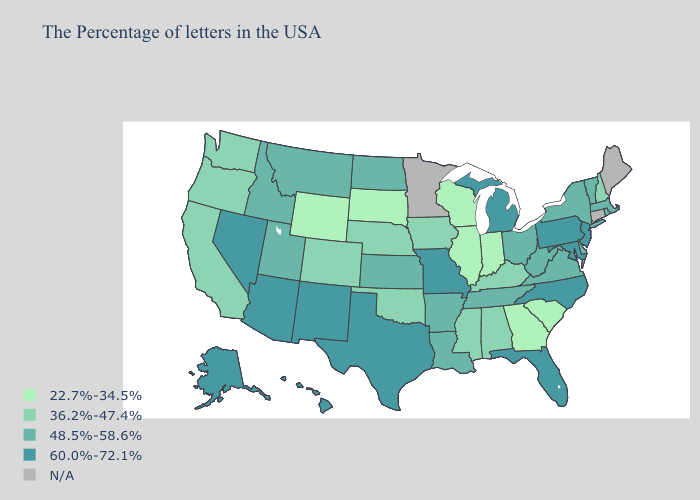What is the value of Washington?
Answer briefly. 36.2%-47.4%. Name the states that have a value in the range 48.5%-58.6%?
Quick response, please. Massachusetts, Rhode Island, Vermont, New York, Delaware, Virginia, West Virginia, Ohio, Tennessee, Louisiana, Arkansas, Kansas, North Dakota, Utah, Montana, Idaho. Does Arkansas have the highest value in the South?
Be succinct. No. What is the value of New York?
Write a very short answer. 48.5%-58.6%. What is the value of Missouri?
Keep it brief. 60.0%-72.1%. Which states have the lowest value in the West?
Answer briefly. Wyoming. Which states have the highest value in the USA?
Be succinct. New Jersey, Maryland, Pennsylvania, North Carolina, Florida, Michigan, Missouri, Texas, New Mexico, Arizona, Nevada, Alaska, Hawaii. Among the states that border Missouri , which have the highest value?
Concise answer only. Tennessee, Arkansas, Kansas. Which states have the highest value in the USA?
Give a very brief answer. New Jersey, Maryland, Pennsylvania, North Carolina, Florida, Michigan, Missouri, Texas, New Mexico, Arizona, Nevada, Alaska, Hawaii. What is the lowest value in the USA?
Answer briefly. 22.7%-34.5%. What is the lowest value in the West?
Concise answer only. 22.7%-34.5%. What is the lowest value in the MidWest?
Be succinct. 22.7%-34.5%. Among the states that border Nebraska , does Colorado have the lowest value?
Quick response, please. No. What is the value of Missouri?
Quick response, please. 60.0%-72.1%. Does Wyoming have the lowest value in the West?
Quick response, please. Yes. 